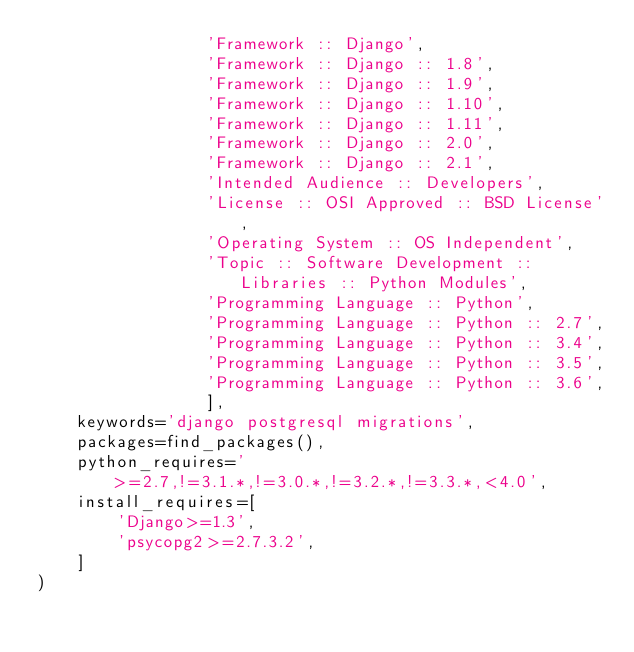<code> <loc_0><loc_0><loc_500><loc_500><_Python_>                 'Framework :: Django',
                 'Framework :: Django :: 1.8',
                 'Framework :: Django :: 1.9',
                 'Framework :: Django :: 1.10',
                 'Framework :: Django :: 1.11',
                 'Framework :: Django :: 2.0',
                 'Framework :: Django :: 2.1',
                 'Intended Audience :: Developers',
                 'License :: OSI Approved :: BSD License',
                 'Operating System :: OS Independent',
                 'Topic :: Software Development :: Libraries :: Python Modules',
                 'Programming Language :: Python',
                 'Programming Language :: Python :: 2.7',
                 'Programming Language :: Python :: 3.4',
                 'Programming Language :: Python :: 3.5',
                 'Programming Language :: Python :: 3.6',
                 ],
    keywords='django postgresql migrations',
    packages=find_packages(),
    python_requires='>=2.7,!=3.1.*,!=3.0.*,!=3.2.*,!=3.3.*,<4.0',
    install_requires=[
        'Django>=1.3',
        'psycopg2>=2.7.3.2',
    ]
)
</code> 